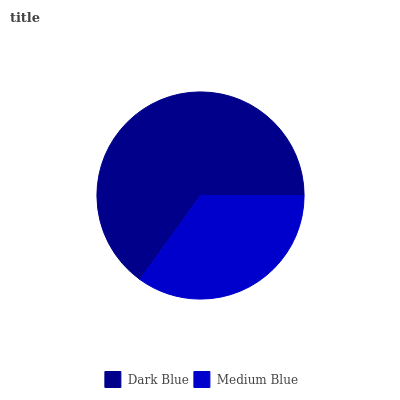Is Medium Blue the minimum?
Answer yes or no. Yes. Is Dark Blue the maximum?
Answer yes or no. Yes. Is Medium Blue the maximum?
Answer yes or no. No. Is Dark Blue greater than Medium Blue?
Answer yes or no. Yes. Is Medium Blue less than Dark Blue?
Answer yes or no. Yes. Is Medium Blue greater than Dark Blue?
Answer yes or no. No. Is Dark Blue less than Medium Blue?
Answer yes or no. No. Is Dark Blue the high median?
Answer yes or no. Yes. Is Medium Blue the low median?
Answer yes or no. Yes. Is Medium Blue the high median?
Answer yes or no. No. Is Dark Blue the low median?
Answer yes or no. No. 